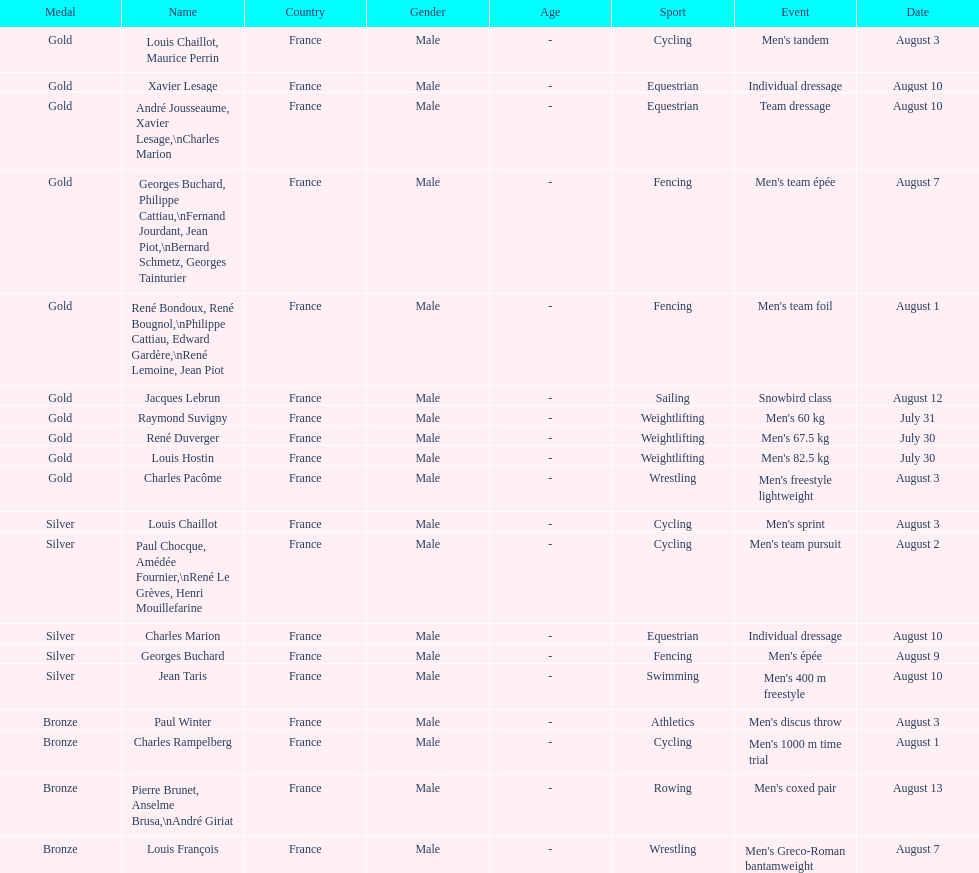Could you parse the entire table? {'header': ['Medal', 'Name', 'Country', 'Gender', 'Age', 'Sport', 'Event', 'Date'], 'rows': [['Gold', 'Louis Chaillot, Maurice Perrin', 'France', 'Male', '-', 'Cycling', "Men's tandem", 'August 3'], ['Gold', 'Xavier Lesage', 'France', 'Male', '-', 'Equestrian', 'Individual dressage', 'August 10'], ['Gold', 'André Jousseaume, Xavier Lesage,\\nCharles Marion', 'France', 'Male', '-', 'Equestrian', 'Team dressage', 'August 10'], ['Gold', 'Georges Buchard, Philippe Cattiau,\\nFernand Jourdant, Jean Piot,\\nBernard Schmetz, Georges Tainturier', 'France', 'Male', '-', 'Fencing', "Men's team épée", 'August 7'], ['Gold', 'René Bondoux, René Bougnol,\\nPhilippe Cattiau, Edward Gardère,\\nRené Lemoine, Jean Piot', 'France', 'Male', '-', 'Fencing', "Men's team foil", 'August 1'], ['Gold', 'Jacques Lebrun', 'France', 'Male', '-', 'Sailing', 'Snowbird class', 'August 12'], ['Gold', 'Raymond Suvigny', 'France', 'Male', '-', 'Weightlifting', "Men's 60 kg", 'July 31'], ['Gold', 'René Duverger', 'France', 'Male', '-', 'Weightlifting', "Men's 67.5 kg", 'July 30'], ['Gold', 'Louis Hostin', 'France', 'Male', '-', 'Weightlifting', "Men's 82.5 kg", 'July 30'], ['Gold', 'Charles Pacôme', 'France', 'Male', '-', 'Wrestling', "Men's freestyle lightweight", 'August 3'], ['Silver', 'Louis Chaillot', 'France', 'Male', '-', 'Cycling', "Men's sprint", 'August 3'], ['Silver', 'Paul Chocque, Amédée Fournier,\\nRené Le Grèves, Henri Mouillefarine', 'France', 'Male', '-', 'Cycling', "Men's team pursuit", 'August 2'], ['Silver', 'Charles Marion', 'France', 'Male', '-', 'Equestrian', 'Individual dressage', 'August 10'], ['Silver', 'Georges Buchard', 'France', 'Male', '-', 'Fencing', "Men's épée", 'August 9'], ['Silver', 'Jean Taris', 'France', 'Male', '-', 'Swimming', "Men's 400 m freestyle", 'August 10'], ['Bronze', 'Paul Winter', 'France', 'Male', '-', 'Athletics', "Men's discus throw", 'August 3'], ['Bronze', 'Charles Rampelberg', 'France', 'Male', '-', 'Cycling', "Men's 1000 m time trial", 'August 1'], ['Bronze', 'Pierre Brunet, Anselme Brusa,\\nAndré Giriat', 'France', 'Male', '-', 'Rowing', "Men's coxed pair", 'August 13'], ['Bronze', 'Louis François', 'France', 'Male', '-', 'Wrestling', "Men's Greco-Roman bantamweight", 'August 7']]} Which event won the most medals? Cycling. 